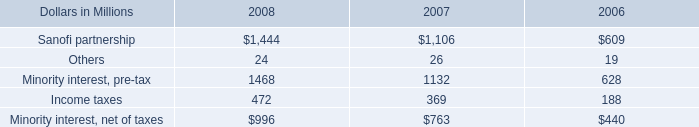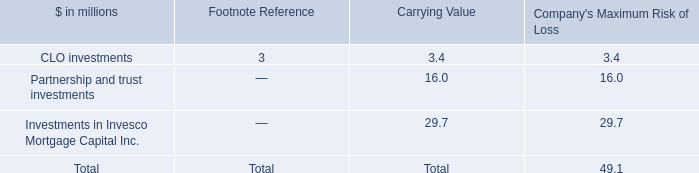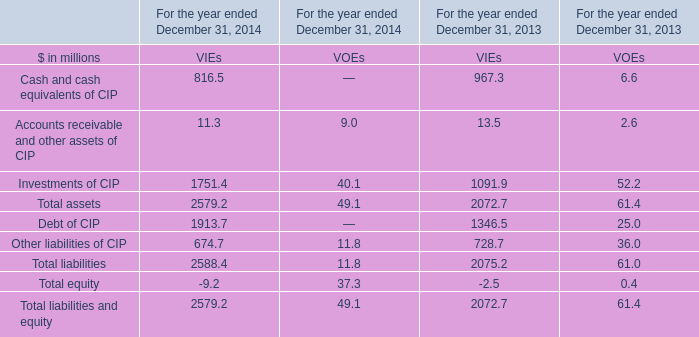In what year is Accounts receivable and other assets of CIP forVIEs positive? 
Answer: For the year ended December 31, 2014 For the year ended December 31, 2013. 